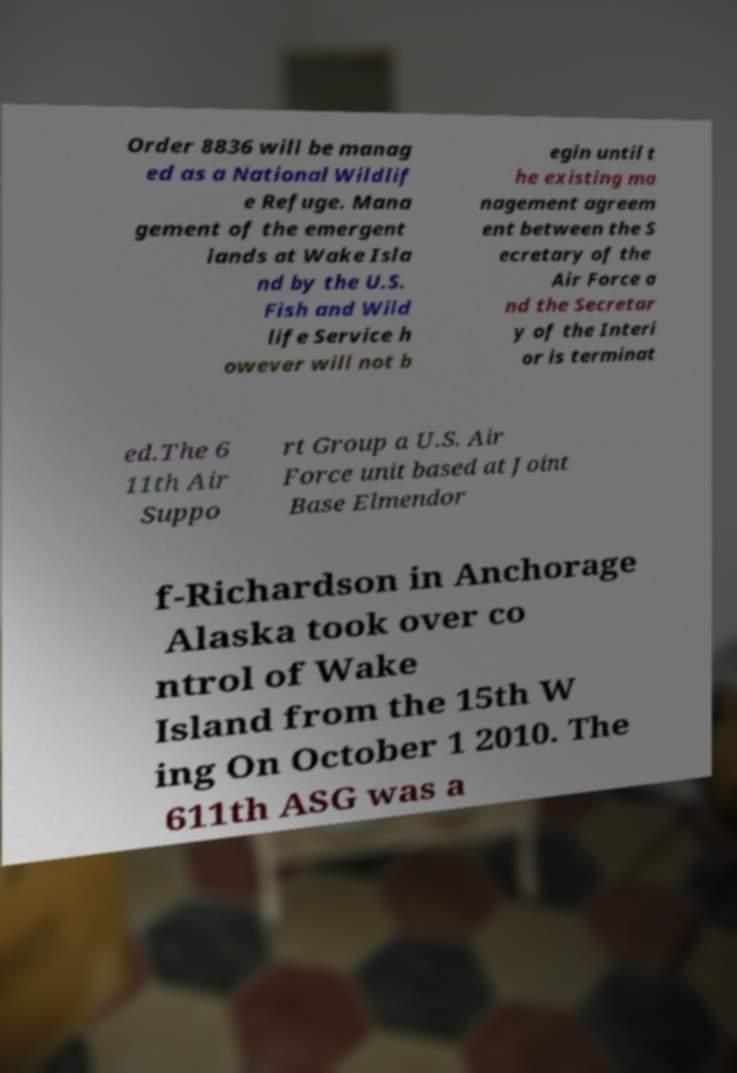Could you assist in decoding the text presented in this image and type it out clearly? Order 8836 will be manag ed as a National Wildlif e Refuge. Mana gement of the emergent lands at Wake Isla nd by the U.S. Fish and Wild life Service h owever will not b egin until t he existing ma nagement agreem ent between the S ecretary of the Air Force a nd the Secretar y of the Interi or is terminat ed.The 6 11th Air Suppo rt Group a U.S. Air Force unit based at Joint Base Elmendor f-Richardson in Anchorage Alaska took over co ntrol of Wake Island from the 15th W ing On October 1 2010. The 611th ASG was a 